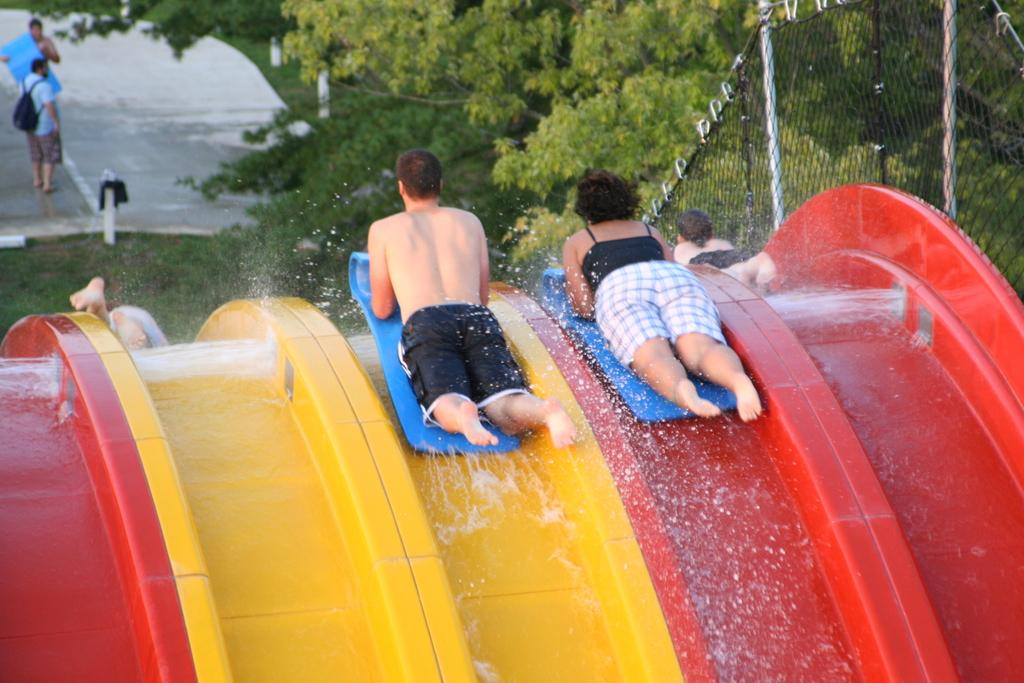What are the two persons in the image using for support in the water? The two persons in the image are using swimming boards for support in the water. What are the persons doing on the slides? The persons are on slides in the image. What type of vegetation can be seen in the image? There are trees visible in the image. What is the purpose of the wire fence in the image? The wire fence in the image serves as a barrier or boundary. How many persons are standing in the image? There are two persons standing in the image. What type of ground surface is visible in the image? There is grass visible in the image. How far does the crib need to be pushed to reach the persons on the slides? There is no crib present in the image, so it is not possible to determine the distance required to reach the persons on the slides. What force is being applied by the persons on the slides? The image does not provide information about the force being applied by the persons on the slides, as it only shows them on the slides. 